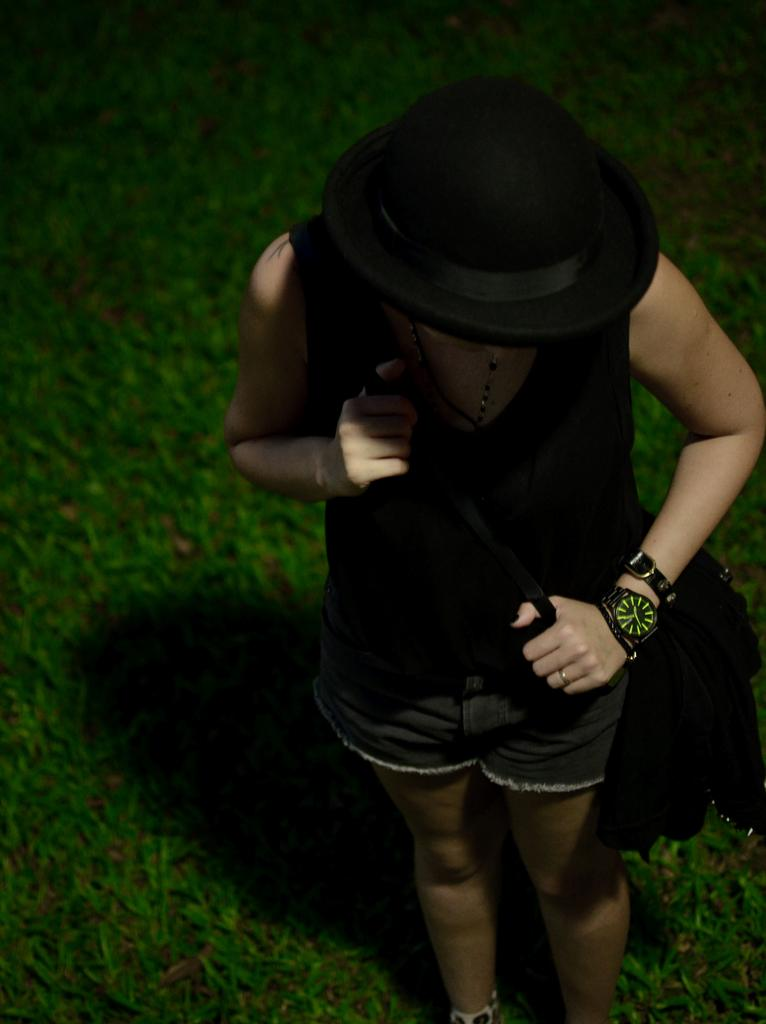How is the image taken in relation to the subject? The image is taken from an upside angle. Can you describe the person in the image? The person is wearing a black hat and is carrying a bag. What accessory is the person wearing on their wrist? The person is wearing a watch. What type of surface is the person standing on? The person is standing on the grass. What type of cream is being processed in the image? There is no cream or process being depicted in the image; it features a person standing on grass while wearing a black hat, a watch, and carrying a bag. 